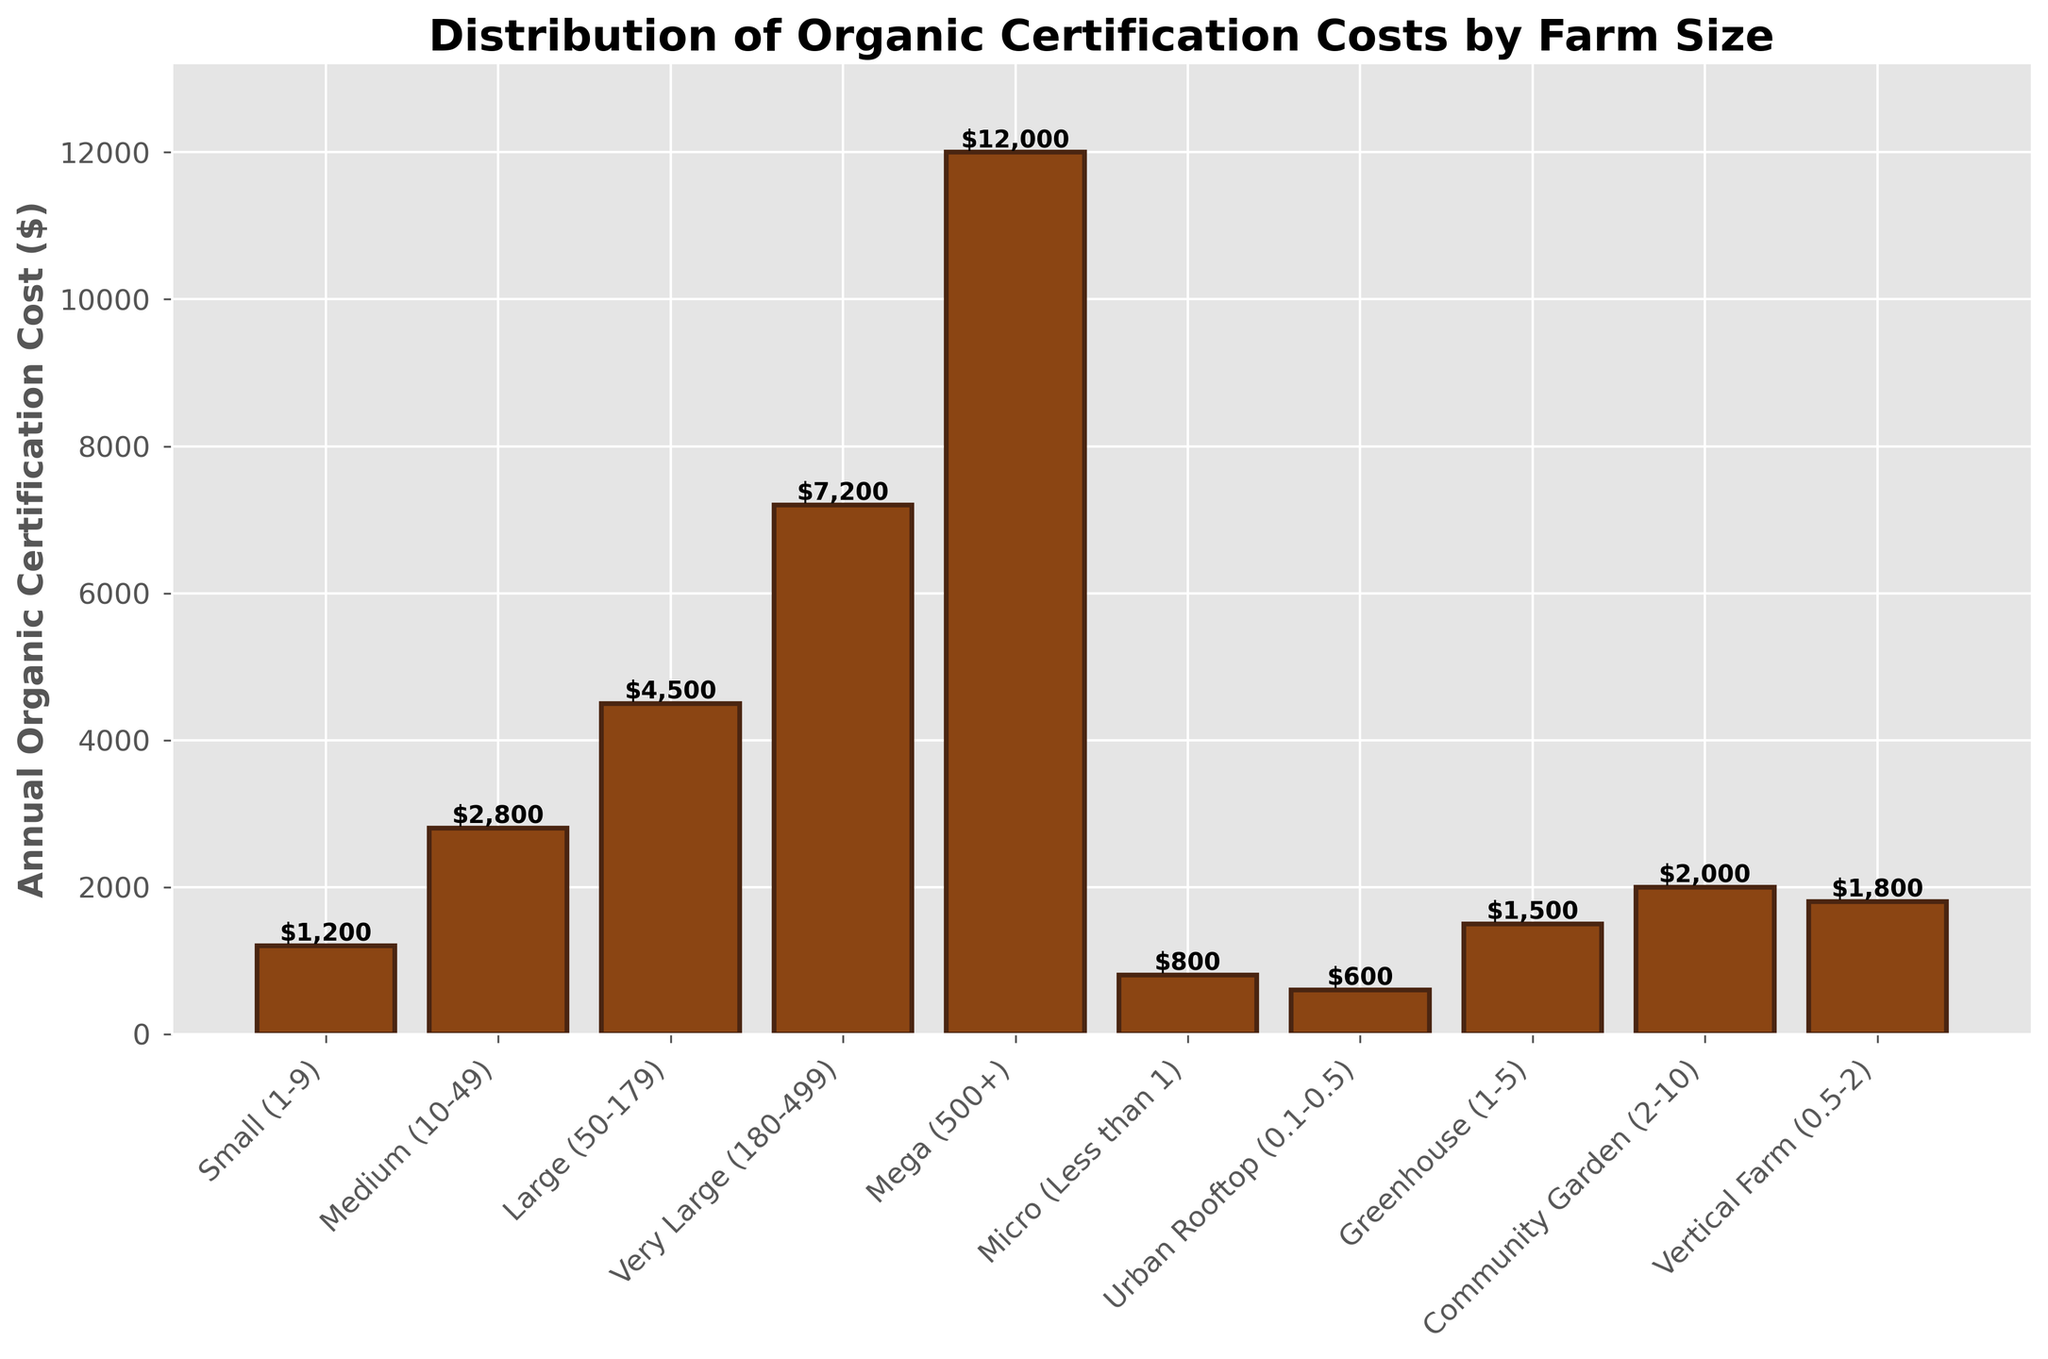Which farm size has the highest annual organic certification cost? The vertical height of the bars represents the certification costs. The bar representing the "Mega (500+)" farm size is the tallest.
Answer: Mega (500+) How much more does a large (50-179 acres) farm pay compared to a community garden (2-10 acres) for annual organic certification? Identify the height of the "Large (50-179)" bar and the "Community Garden (2-10)" bar. Subtract the community garden cost ($2000) from the large farm cost ($4500).
Answer: $2500 What is the total annual organic certification cost for a small (1-9 acres) and an urban rooftop (0.1-0.5 acres) farm combined? Sum the costs represented by the bars for "Small (1-9)" ($1200) and "Urban Rooftop (0.1-0.5)" ($600).
Answer: $1800 Which farm size has a lower annual certification cost, a vertical farm (0.5-2 acres) or a greenhouse (1-5 acres)? Compare the heights of the bars for "Vertical Farm (0.5-2)" and "Greenhouse (1-5)". The bar for the vertical farm is shorter.
Answer: Vertical Farm (0.5-2) What is the average annual organic certification cost for the community garden (2-10 acres), vertical farm (0.5-2 acres), and large (50-179 acres) farm sizes? Sum the costs of the community garden ($2000), vertical farm ($1800), and large farm ($4500). Divide by 3 to get the average.
Answer: $2767 Which farm sizes have certification costs below $1500 annually? Check the heights of all bars and list those with costs below the $1500 mark. These are "Micro (Less than 1)", "Urban Rooftop (0.1-0.5)", and "Small (1-9)".
Answer: Micro (Less than 1), Urban Rooftop (0.1-0.5), Small (1-9) Rank the following farm sizes by their annual certification costs from lowest to highest: Mega (500+), Medium (10-49), Small (1-9). Compare the bar heights for Mega ($12000), Medium ($2800), and Small ($1200) and order them accordingly.
Answer: Small (1-9), Medium (10-49), Mega (500+) By how much does the certification cost increase when moving from a medium (10-49 acres) farm to a very large (180-499 acres) farm? Subtract the certification cost of the medium farm ($2800) from the very large farm ($7200).
Answer: $4400 What is the difference in certification cost between a micro farm (less than 1 acre) and a community garden (2-10 acres)? Subtract the cost of the micro farm ($800) from the community garden ($2000).
Answer: $1200 What is the combined annual certification cost for all farm sizes listed? Sum the costs for all the farm sizes: $800 + $600 + $1200 + $1500 + $2000 + $1800 + $2800 + $4500 + $7200 + $12000.
Answer: $34,400 